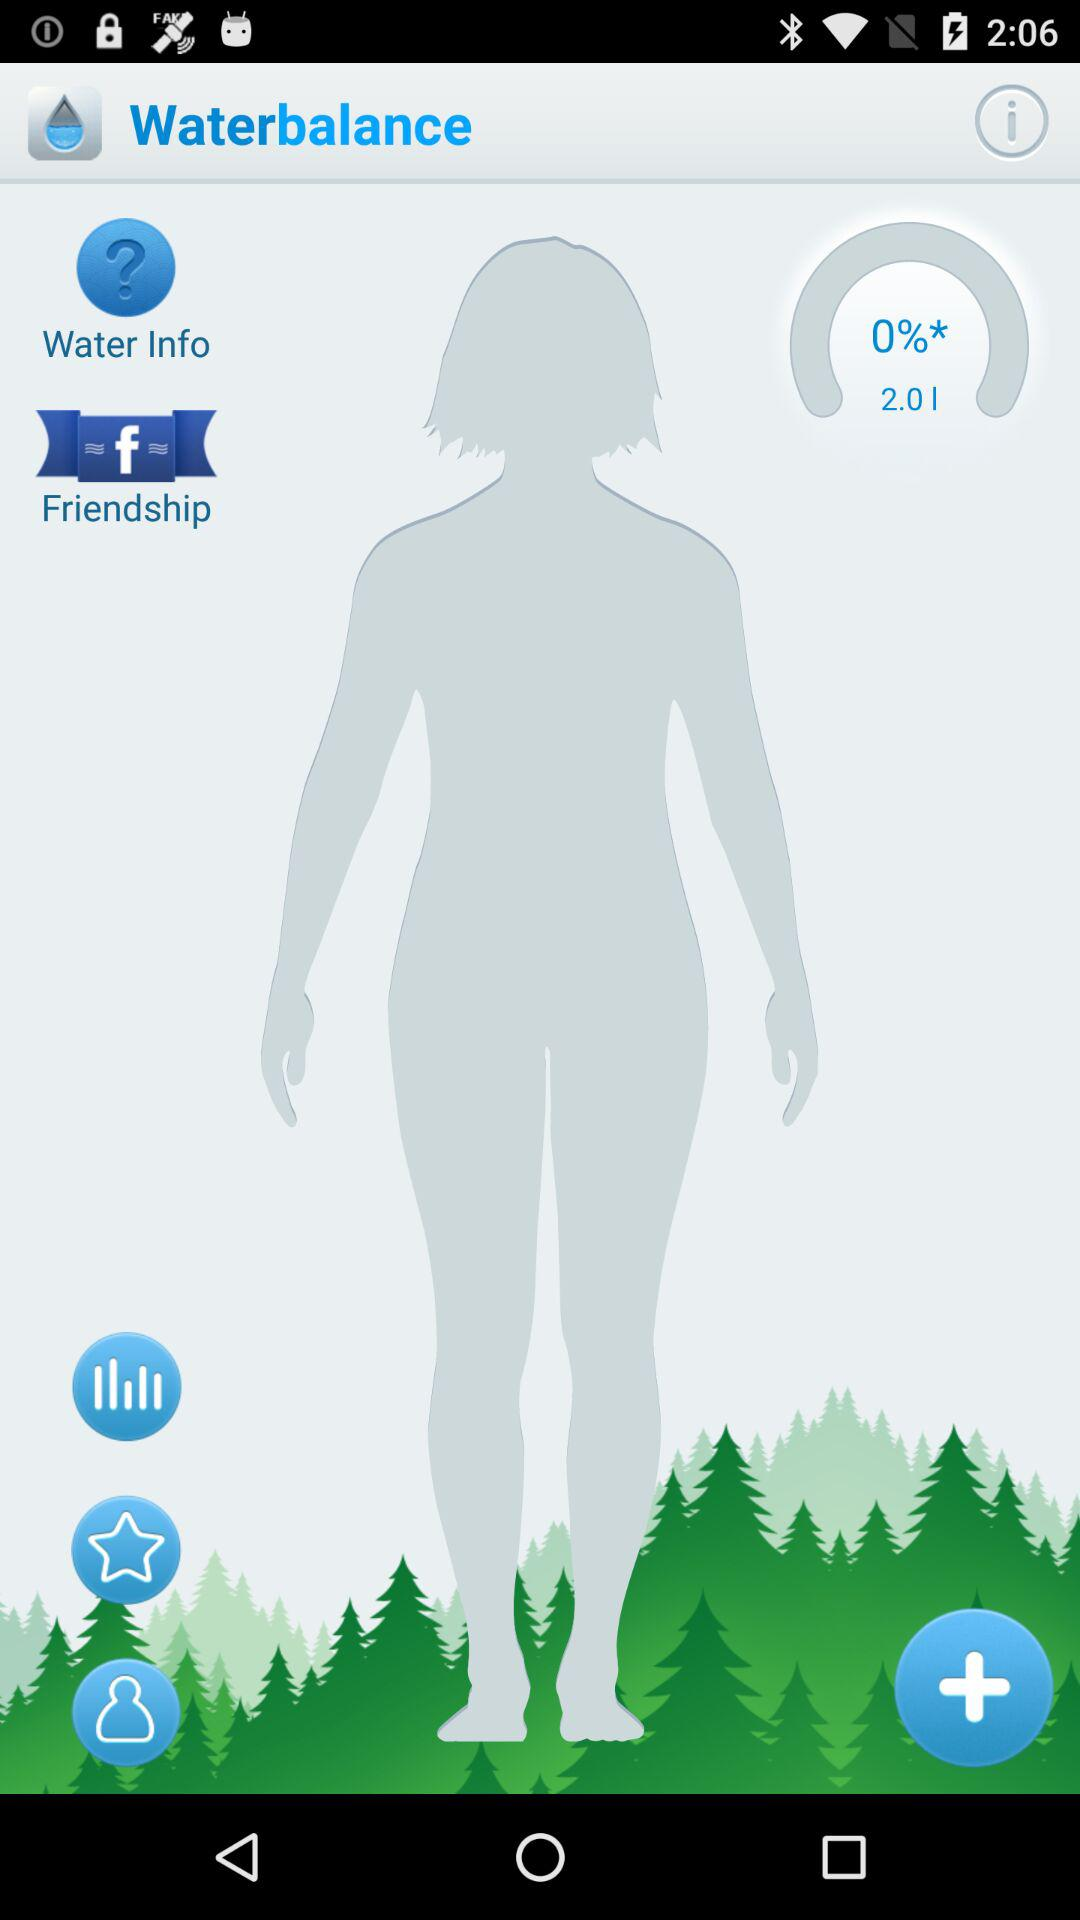What is the version of this application?
When the provided information is insufficient, respond with <no answer>. <no answer> 